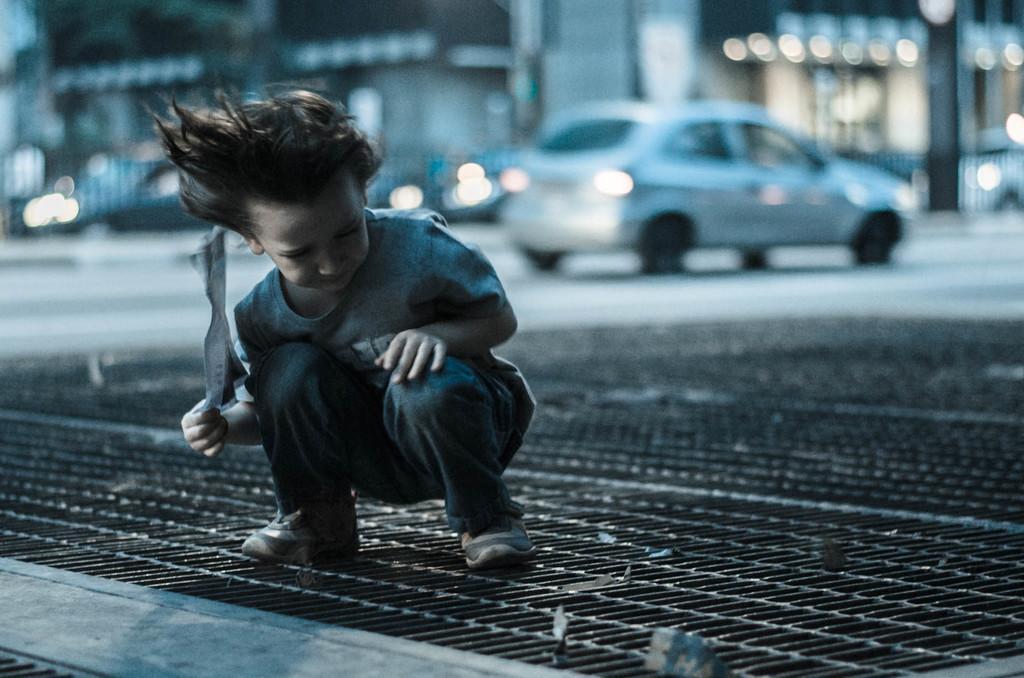Could you give a brief overview of what you see in this image? In the center of the image we can see a kid on the mesh. And we can see the kid is holding some object. In the background, we can see a vehicle, lights and a few other objects. 